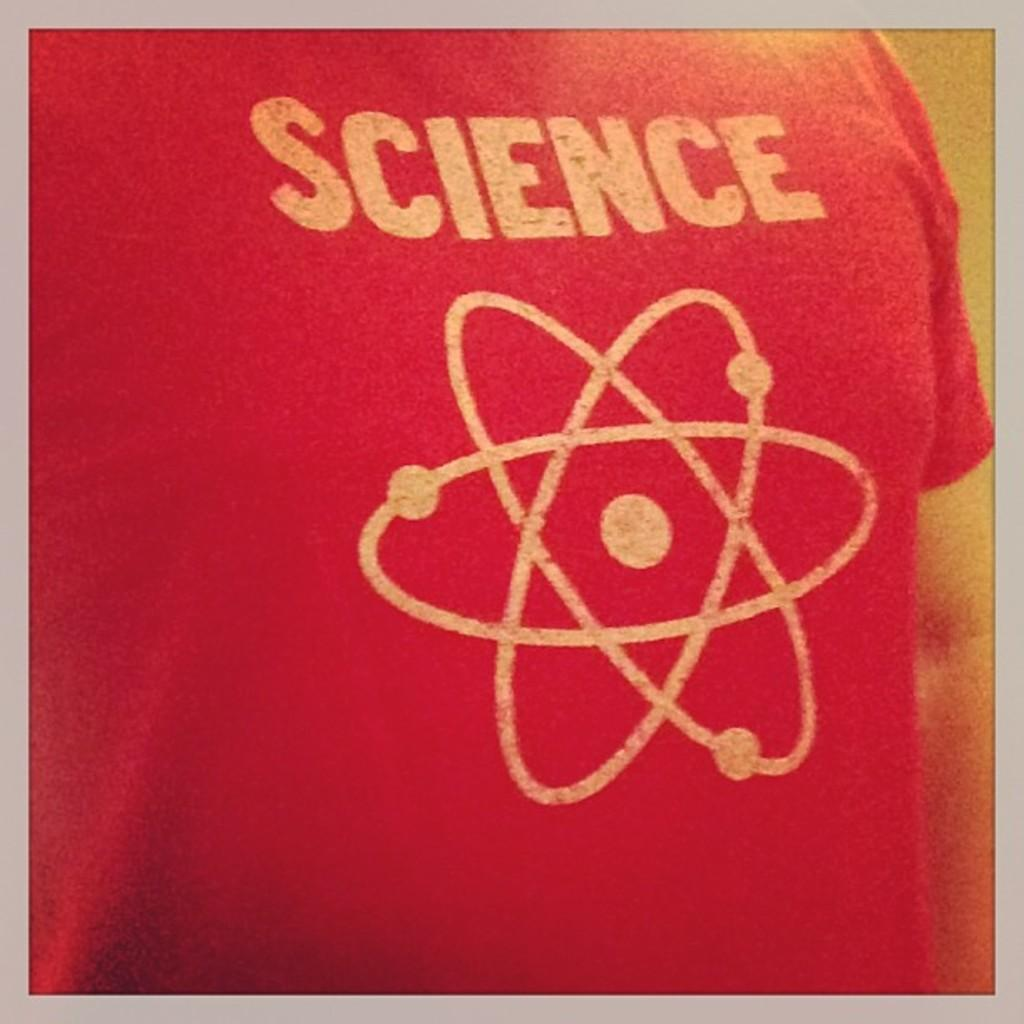<image>
Provide a brief description of the given image. A person wearing a red t shirt with "Science" printed over a Spirograph design. 